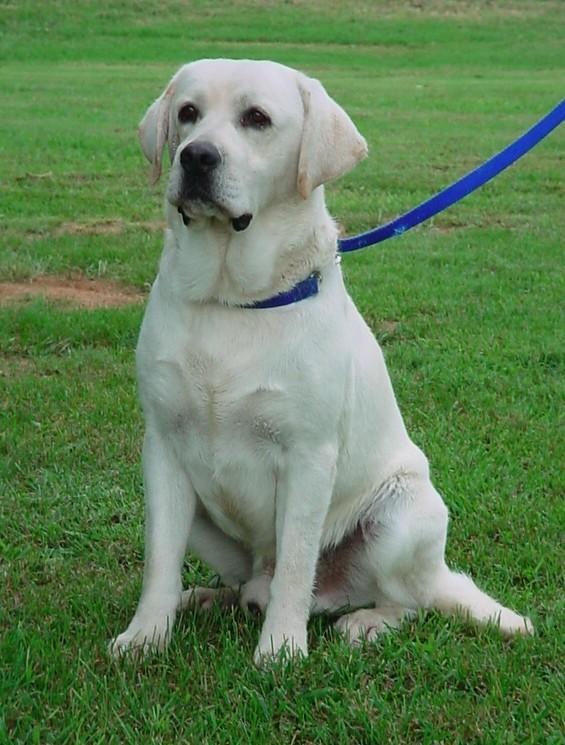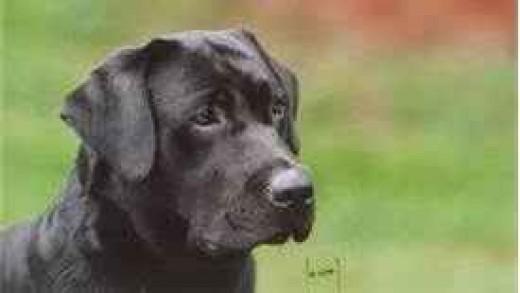The first image is the image on the left, the second image is the image on the right. For the images displayed, is the sentence "There is at least one dog wearing a leash" factually correct? Answer yes or no. Yes. The first image is the image on the left, the second image is the image on the right. Examine the images to the left and right. Is the description "The left image includes a royal blue leash and an adult white dog sitting upright on green grass." accurate? Answer yes or no. Yes. 